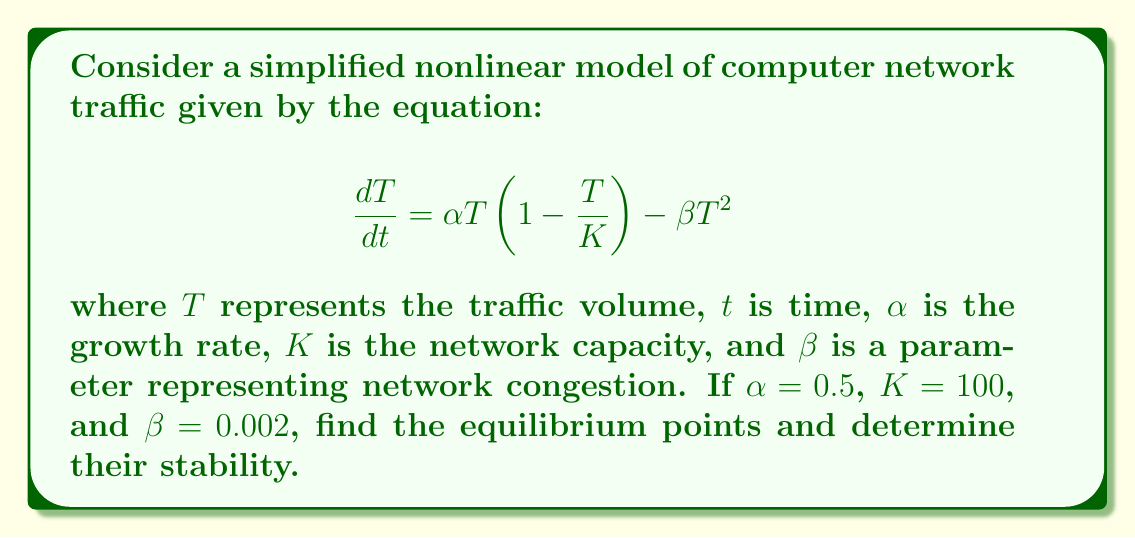Teach me how to tackle this problem. To analyze the stability of this nonlinear system, we'll follow these steps:

1. Find the equilibrium points by setting $\frac{dT}{dt} = 0$:

   $$0 = \alpha T(1-\frac{T}{K}) - \beta T^2$$
   $$0 = 0.5T(1-\frac{T}{100}) - 0.002T^2$$
   $$0 = 0.5T - 0.005T^2 - 0.002T^2$$
   $$0 = T(0.5 - 0.007T)$$

   Solving this equation, we get:
   $T = 0$ or $T \approx 71.43$

2. Evaluate the derivative of $\frac{dT}{dt}$ with respect to $T$:

   $$\frac{d}{dT}(\frac{dT}{dt}) = \alpha (1-\frac{2T}{K}) - 2\beta T$$
   $$\frac{d}{dT}(\frac{dT}{dt}) = 0.5(1-\frac{2T}{100}) - 2(0.002)T$$
   $$\frac{d}{dT}(\frac{dT}{dt}) = 0.5 - 0.01T - 0.004T$$
   $$\frac{d}{dT}(\frac{dT}{dt}) = 0.5 - 0.014T$$

3. Evaluate the derivative at each equilibrium point:

   At $T = 0$: $0.5 - 0.014(0) = 0.5 > 0$
   At $T = 71.43$: $0.5 - 0.014(71.43) \approx -0.5 < 0$

4. Interpret the results:
   - For $T = 0$, the derivative is positive, indicating an unstable equilibrium point.
   - For $T = 71.43$, the derivative is negative, indicating a stable equilibrium point.
Answer: Two equilibrium points: $T = 0$ (unstable) and $T \approx 71.43$ (stable). 